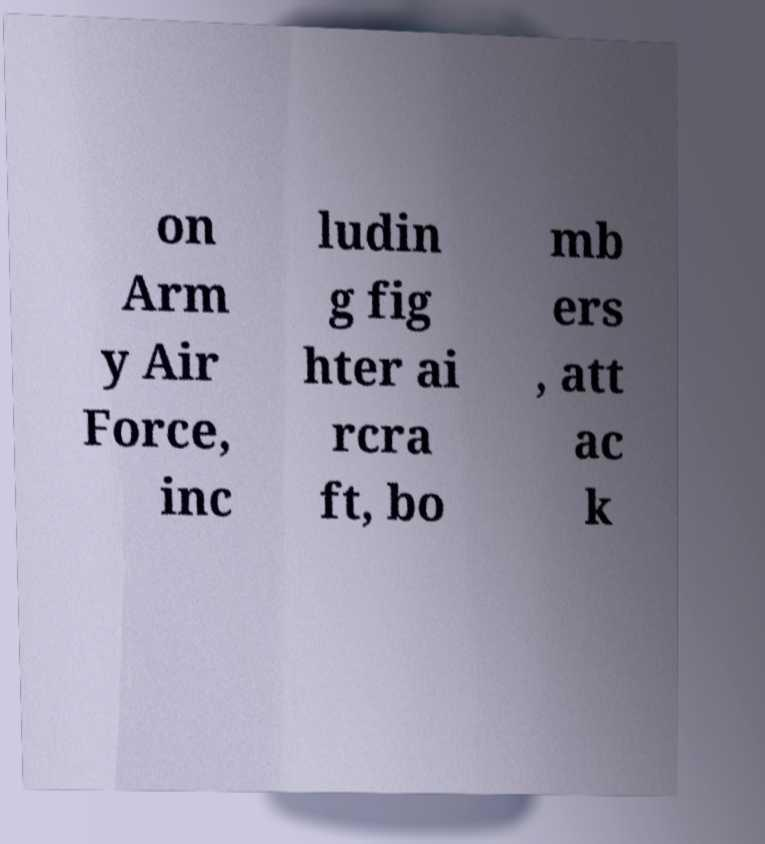There's text embedded in this image that I need extracted. Can you transcribe it verbatim? on Arm y Air Force, inc ludin g fig hter ai rcra ft, bo mb ers , att ac k 